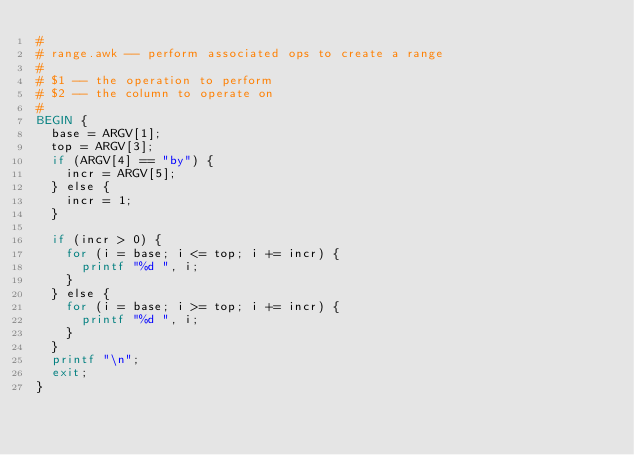<code> <loc_0><loc_0><loc_500><loc_500><_Awk_>#
# range.awk -- perform associated ops to create a range
#
#	$1 -- the operation to perform
#	$2 -- the column to operate on
#
BEGIN {
	base = ARGV[1];
	top = ARGV[3];
	if (ARGV[4] == "by") {
		incr = ARGV[5];
	} else {
		incr = 1;
	}

	if (incr > 0) {
		for (i = base; i <= top; i += incr) {
			printf "%d ", i;
		}
	} else {
		for (i = base; i >= top; i += incr) {
			printf "%d ", i;
		}
	}
	printf "\n";
	exit;
}
</code> 